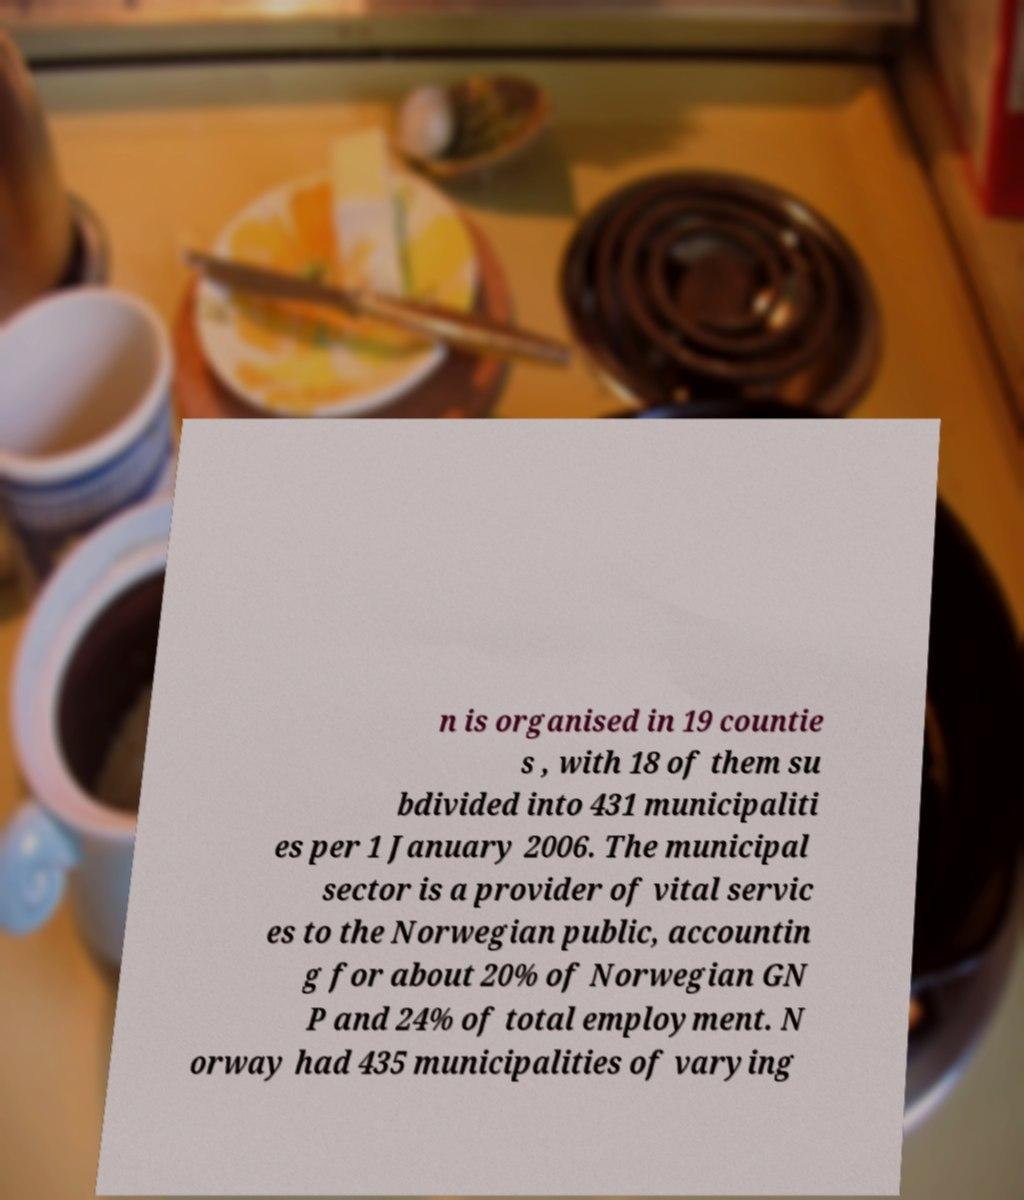What messages or text are displayed in this image? I need them in a readable, typed format. n is organised in 19 countie s , with 18 of them su bdivided into 431 municipaliti es per 1 January 2006. The municipal sector is a provider of vital servic es to the Norwegian public, accountin g for about 20% of Norwegian GN P and 24% of total employment. N orway had 435 municipalities of varying 